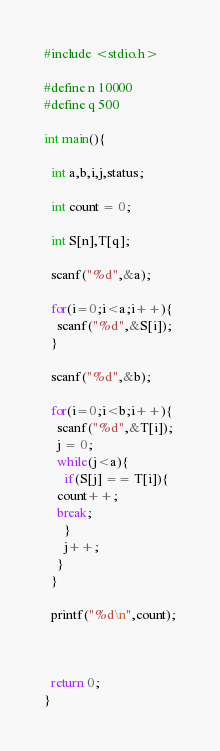Convert code to text. <code><loc_0><loc_0><loc_500><loc_500><_C_>#include <stdio.h>

#define n 10000
#define q 500

int main(){

  int a,b,i,j,status;

  int count = 0;
  
  int S[n],T[q];
  
  scanf("%d",&a);

  for(i=0;i<a;i++){
    scanf("%d",&S[i]);
  }

  scanf("%d",&b);

  for(i=0;i<b;i++){
    scanf("%d",&T[i]);
    j = 0;
    while(j<a){
      if(S[j] == T[i]){
	count++;
	break;
      }
      j++;
    }
  }

  printf("%d\n",count);



  return 0;
}

</code> 